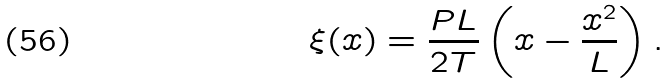Convert formula to latex. <formula><loc_0><loc_0><loc_500><loc_500>\xi ( x ) = \frac { P L } { 2 T } \left ( x - \frac { x ^ { 2 } } { L } \right ) .</formula> 